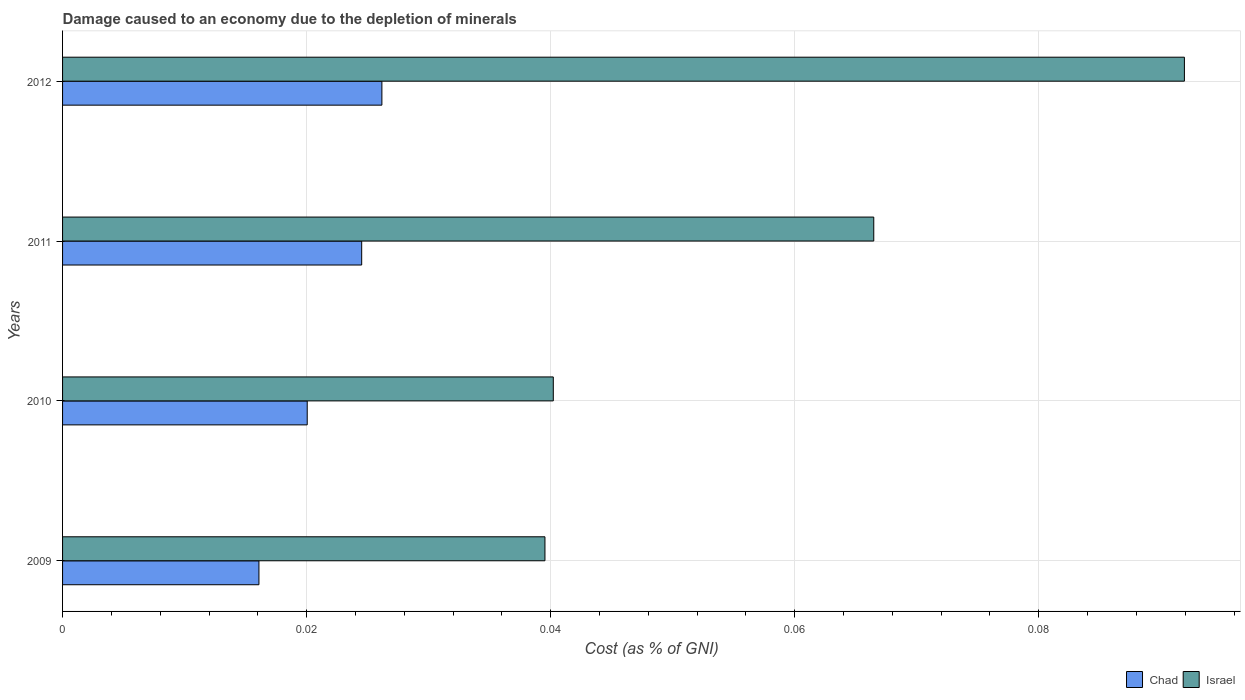How many groups of bars are there?
Offer a terse response. 4. Are the number of bars on each tick of the Y-axis equal?
Your answer should be compact. Yes. How many bars are there on the 3rd tick from the top?
Your answer should be compact. 2. What is the label of the 2nd group of bars from the top?
Make the answer very short. 2011. What is the cost of damage caused due to the depletion of minerals in Chad in 2012?
Provide a succinct answer. 0.03. Across all years, what is the maximum cost of damage caused due to the depletion of minerals in Israel?
Provide a short and direct response. 0.09. Across all years, what is the minimum cost of damage caused due to the depletion of minerals in Israel?
Make the answer very short. 0.04. In which year was the cost of damage caused due to the depletion of minerals in Israel maximum?
Offer a very short reply. 2012. What is the total cost of damage caused due to the depletion of minerals in Israel in the graph?
Ensure brevity in your answer.  0.24. What is the difference between the cost of damage caused due to the depletion of minerals in Israel in 2010 and that in 2012?
Provide a succinct answer. -0.05. What is the difference between the cost of damage caused due to the depletion of minerals in Chad in 2011 and the cost of damage caused due to the depletion of minerals in Israel in 2012?
Make the answer very short. -0.07. What is the average cost of damage caused due to the depletion of minerals in Chad per year?
Your answer should be compact. 0.02. In the year 2009, what is the difference between the cost of damage caused due to the depletion of minerals in Chad and cost of damage caused due to the depletion of minerals in Israel?
Provide a succinct answer. -0.02. In how many years, is the cost of damage caused due to the depletion of minerals in Chad greater than 0.028 %?
Your response must be concise. 0. What is the ratio of the cost of damage caused due to the depletion of minerals in Israel in 2009 to that in 2012?
Make the answer very short. 0.43. What is the difference between the highest and the second highest cost of damage caused due to the depletion of minerals in Chad?
Keep it short and to the point. 0. What is the difference between the highest and the lowest cost of damage caused due to the depletion of minerals in Chad?
Ensure brevity in your answer.  0.01. What does the 2nd bar from the top in 2010 represents?
Provide a short and direct response. Chad. What does the 2nd bar from the bottom in 2012 represents?
Keep it short and to the point. Israel. How many bars are there?
Your answer should be compact. 8. Does the graph contain any zero values?
Provide a short and direct response. No. How many legend labels are there?
Your answer should be very brief. 2. How are the legend labels stacked?
Offer a very short reply. Horizontal. What is the title of the graph?
Provide a succinct answer. Damage caused to an economy due to the depletion of minerals. What is the label or title of the X-axis?
Your answer should be compact. Cost (as % of GNI). What is the Cost (as % of GNI) in Chad in 2009?
Give a very brief answer. 0.02. What is the Cost (as % of GNI) of Israel in 2009?
Your response must be concise. 0.04. What is the Cost (as % of GNI) in Chad in 2010?
Keep it short and to the point. 0.02. What is the Cost (as % of GNI) of Israel in 2010?
Give a very brief answer. 0.04. What is the Cost (as % of GNI) of Chad in 2011?
Your answer should be very brief. 0.02. What is the Cost (as % of GNI) of Israel in 2011?
Offer a terse response. 0.07. What is the Cost (as % of GNI) of Chad in 2012?
Offer a very short reply. 0.03. What is the Cost (as % of GNI) of Israel in 2012?
Your answer should be compact. 0.09. Across all years, what is the maximum Cost (as % of GNI) of Chad?
Your answer should be compact. 0.03. Across all years, what is the maximum Cost (as % of GNI) in Israel?
Give a very brief answer. 0.09. Across all years, what is the minimum Cost (as % of GNI) of Chad?
Make the answer very short. 0.02. Across all years, what is the minimum Cost (as % of GNI) in Israel?
Offer a very short reply. 0.04. What is the total Cost (as % of GNI) of Chad in the graph?
Provide a succinct answer. 0.09. What is the total Cost (as % of GNI) of Israel in the graph?
Your response must be concise. 0.24. What is the difference between the Cost (as % of GNI) of Chad in 2009 and that in 2010?
Give a very brief answer. -0. What is the difference between the Cost (as % of GNI) in Israel in 2009 and that in 2010?
Your answer should be very brief. -0. What is the difference between the Cost (as % of GNI) of Chad in 2009 and that in 2011?
Ensure brevity in your answer.  -0.01. What is the difference between the Cost (as % of GNI) in Israel in 2009 and that in 2011?
Offer a terse response. -0.03. What is the difference between the Cost (as % of GNI) of Chad in 2009 and that in 2012?
Provide a succinct answer. -0.01. What is the difference between the Cost (as % of GNI) of Israel in 2009 and that in 2012?
Provide a succinct answer. -0.05. What is the difference between the Cost (as % of GNI) in Chad in 2010 and that in 2011?
Make the answer very short. -0. What is the difference between the Cost (as % of GNI) in Israel in 2010 and that in 2011?
Your answer should be very brief. -0.03. What is the difference between the Cost (as % of GNI) of Chad in 2010 and that in 2012?
Make the answer very short. -0.01. What is the difference between the Cost (as % of GNI) in Israel in 2010 and that in 2012?
Keep it short and to the point. -0.05. What is the difference between the Cost (as % of GNI) of Chad in 2011 and that in 2012?
Your answer should be very brief. -0. What is the difference between the Cost (as % of GNI) in Israel in 2011 and that in 2012?
Offer a very short reply. -0.03. What is the difference between the Cost (as % of GNI) in Chad in 2009 and the Cost (as % of GNI) in Israel in 2010?
Provide a short and direct response. -0.02. What is the difference between the Cost (as % of GNI) in Chad in 2009 and the Cost (as % of GNI) in Israel in 2011?
Offer a very short reply. -0.05. What is the difference between the Cost (as % of GNI) of Chad in 2009 and the Cost (as % of GNI) of Israel in 2012?
Offer a terse response. -0.08. What is the difference between the Cost (as % of GNI) of Chad in 2010 and the Cost (as % of GNI) of Israel in 2011?
Your answer should be very brief. -0.05. What is the difference between the Cost (as % of GNI) in Chad in 2010 and the Cost (as % of GNI) in Israel in 2012?
Make the answer very short. -0.07. What is the difference between the Cost (as % of GNI) in Chad in 2011 and the Cost (as % of GNI) in Israel in 2012?
Your answer should be very brief. -0.07. What is the average Cost (as % of GNI) in Chad per year?
Your answer should be very brief. 0.02. What is the average Cost (as % of GNI) in Israel per year?
Your response must be concise. 0.06. In the year 2009, what is the difference between the Cost (as % of GNI) of Chad and Cost (as % of GNI) of Israel?
Provide a short and direct response. -0.02. In the year 2010, what is the difference between the Cost (as % of GNI) of Chad and Cost (as % of GNI) of Israel?
Your answer should be compact. -0.02. In the year 2011, what is the difference between the Cost (as % of GNI) in Chad and Cost (as % of GNI) in Israel?
Make the answer very short. -0.04. In the year 2012, what is the difference between the Cost (as % of GNI) of Chad and Cost (as % of GNI) of Israel?
Provide a succinct answer. -0.07. What is the ratio of the Cost (as % of GNI) of Chad in 2009 to that in 2010?
Your answer should be compact. 0.8. What is the ratio of the Cost (as % of GNI) in Chad in 2009 to that in 2011?
Your response must be concise. 0.66. What is the ratio of the Cost (as % of GNI) of Israel in 2009 to that in 2011?
Offer a very short reply. 0.59. What is the ratio of the Cost (as % of GNI) of Chad in 2009 to that in 2012?
Offer a very short reply. 0.61. What is the ratio of the Cost (as % of GNI) of Israel in 2009 to that in 2012?
Ensure brevity in your answer.  0.43. What is the ratio of the Cost (as % of GNI) of Chad in 2010 to that in 2011?
Give a very brief answer. 0.82. What is the ratio of the Cost (as % of GNI) in Israel in 2010 to that in 2011?
Ensure brevity in your answer.  0.6. What is the ratio of the Cost (as % of GNI) of Chad in 2010 to that in 2012?
Your response must be concise. 0.77. What is the ratio of the Cost (as % of GNI) in Israel in 2010 to that in 2012?
Your answer should be very brief. 0.44. What is the ratio of the Cost (as % of GNI) in Chad in 2011 to that in 2012?
Your answer should be compact. 0.94. What is the ratio of the Cost (as % of GNI) of Israel in 2011 to that in 2012?
Provide a short and direct response. 0.72. What is the difference between the highest and the second highest Cost (as % of GNI) of Chad?
Your answer should be very brief. 0. What is the difference between the highest and the second highest Cost (as % of GNI) of Israel?
Keep it short and to the point. 0.03. What is the difference between the highest and the lowest Cost (as % of GNI) in Chad?
Keep it short and to the point. 0.01. What is the difference between the highest and the lowest Cost (as % of GNI) in Israel?
Your response must be concise. 0.05. 